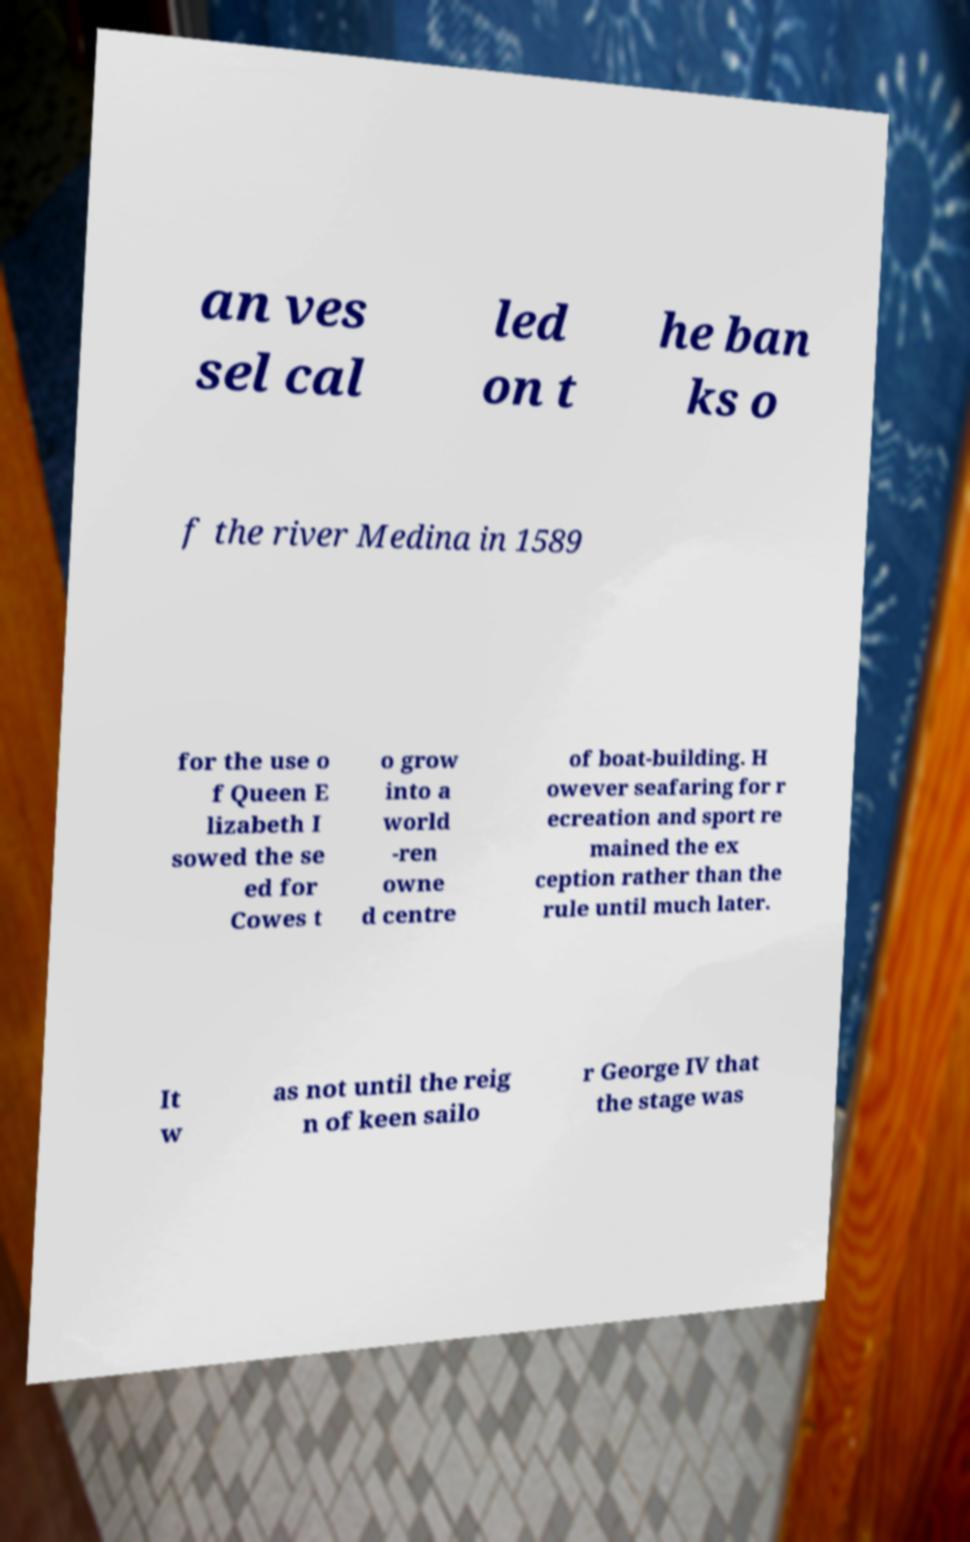Could you extract and type out the text from this image? an ves sel cal led on t he ban ks o f the river Medina in 1589 for the use o f Queen E lizabeth I sowed the se ed for Cowes t o grow into a world -ren owne d centre of boat-building. H owever seafaring for r ecreation and sport re mained the ex ception rather than the rule until much later. It w as not until the reig n of keen sailo r George IV that the stage was 